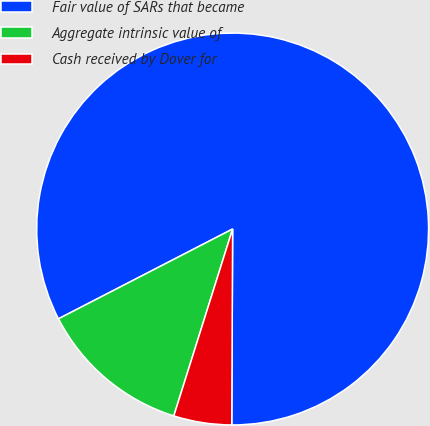<chart> <loc_0><loc_0><loc_500><loc_500><pie_chart><fcel>Fair value of SARs that became<fcel>Aggregate intrinsic value of<fcel>Cash received by Dover for<nl><fcel>82.65%<fcel>12.57%<fcel>4.78%<nl></chart> 